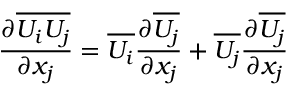Convert formula to latex. <formula><loc_0><loc_0><loc_500><loc_500>{ \frac { \partial \overline { { U _ { i } U _ { j } } } } { \partial x _ { j } } } = \overline { { U _ { i } } } { \frac { \partial \overline { { U _ { j } } } } { \partial x _ { j } } } + \overline { { U _ { j } } } { \frac { \partial \overline { { U _ { j } } } } { \partial x _ { j } } }</formula> 